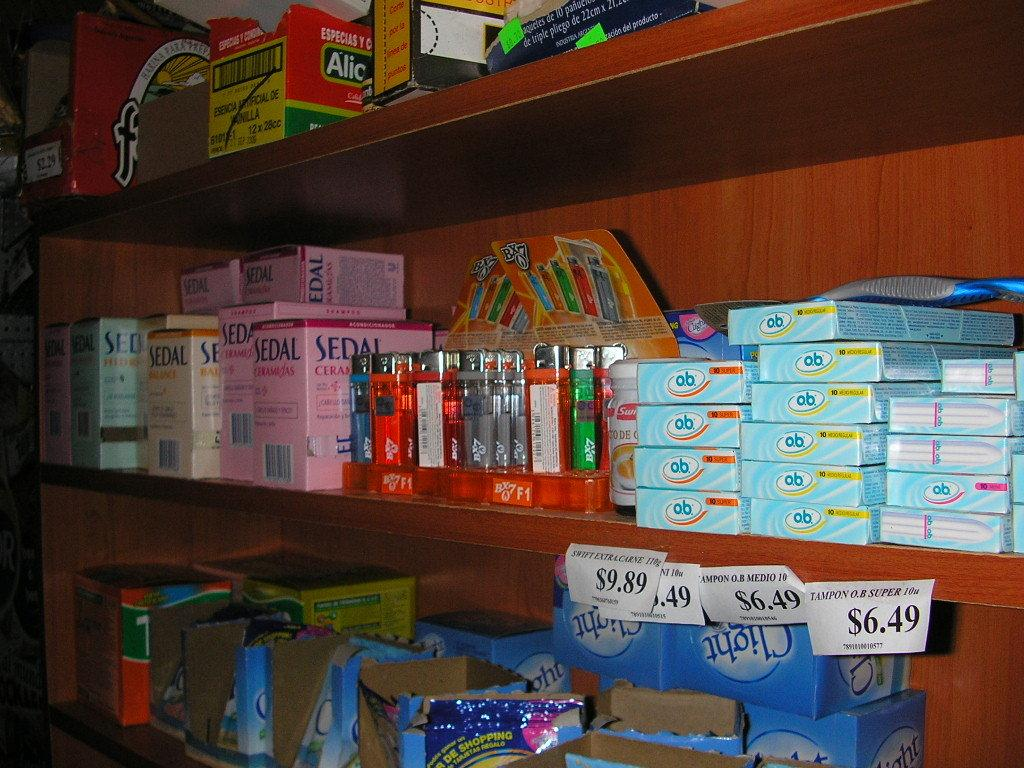<image>
Share a concise interpretation of the image provided. Various items are for sale on a store shelf and one of the items is called Sedal. 